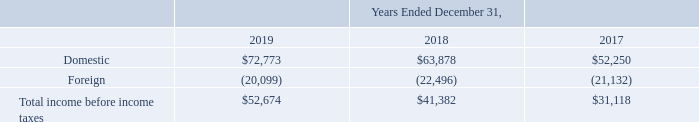5. Income taxes:
On December 22, 2017, the President of the United States signed into law the Tax Cuts and Jobs Act (the "TCJA"). The TCJA amended the Internal Revenue Code and reduced the corporate tax rate from a maximum of 35% to a flat 21% rate. The rate reduction was effective on January 1, 2018. The Company's net deferred tax assets represent a decrease in corporate taxes expected to be paid in the future. Under generally accepted accounting principles deferred tax assets and liabilities are recognized for the future tax consequences attributable to differences between the financial statement carrying amounts of existing assets and liabilities and their respective tax basis. Deferred tax assets and liabilities are measured using enacted tax rates expected to apply to taxable income in the years in which those temporary differences are expected to be recovered or settled. The Company's net deferred tax asset was determined based on the current enacted federal tax rate of 35% prior to the passage of the Act. As a result of the reduction in the corporate income tax rate from 35% to 21% and other provisions under the TCJA, the Company made reasonable estimates of the effects of the TCJA and revalued its net deferred tax asset at December 31, 2017 resulting in a reduction in the value of its net deferred tax asset of approximately $9.0 million and recorded a transition tax of $2.3 million related to its foreign operations for a total of $11.3 million, which was recorded as additional noncash income tax expense in the year ended December 31, 2017. As of December 31, 2018, the Company had collected all of the necessary data to complete its analysis of the effect of the TCJA on its underlying deferred income taxes and recorded a $0.1 million reduction in the value to its net deferred tax asset. The TCJA subjects a U.S. shareholder to current tax on global intangible low-taxed income earned by certain foreign subsidiaries. FASB Staff Q&A, Topic 740, No. 5, "Accounting for Global Intangible Low-Taxed Income", states that the Company is permitted to make an accounting policy election to either recognize deferred income taxes for temporary basis differences expected to reverse as global intangible low-taxed income in future years or provide for the income tax expense related to such income in the year the income tax is incurred. The Company has made an accounting policy to record these income taxes as a period cost in the year the income tax in incurred.
The components of income (loss) before income taxes consist of the following (in thousands):
What are the respective domestic income before income taxes in 2017 and 2018?
Answer scale should be: thousand. $52,250, $63,878. What are the respective domestic income before income taxes in 2018 and 2019?
Answer scale should be: thousand. $63,878, $72,773. What are the respective foreign losses before income taxes in 2017 and 2018?
Answer scale should be: thousand. 21,132, 22,496. What is the average domestic income before income taxes in 2017 and 2018?
Answer scale should be: thousand. ($52,250 + $63,878)/2 
Answer: 58064. What is the average domestic income before income taxes in 2018 and 2019?
Answer scale should be: thousand. ($63,878 + $72,773)/2 
Answer: 68325.5. What is the average foreign losses before income taxes in 2017 and 2018?
Answer scale should be: thousand. (21,132 + 22,496)/2
Answer: 21814. 